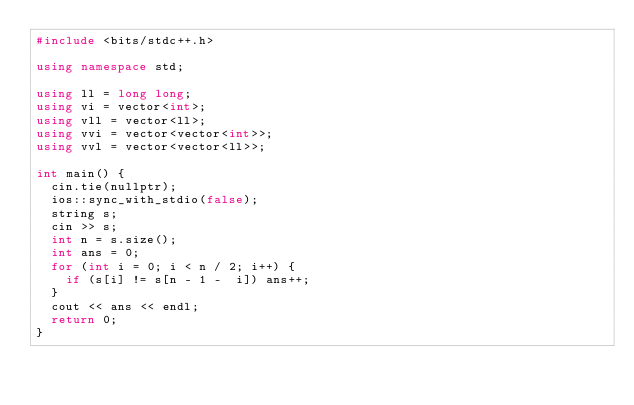Convert code to text. <code><loc_0><loc_0><loc_500><loc_500><_C++_>#include <bits/stdc++.h>

using namespace std;

using ll = long long;
using vi = vector<int>;
using vll = vector<ll>;
using vvi = vector<vector<int>>;
using vvl = vector<vector<ll>>;

int main() {
  cin.tie(nullptr);
  ios::sync_with_stdio(false);
  string s;
  cin >> s;
  int n = s.size();
  int ans = 0;
  for (int i = 0; i < n / 2; i++) {
    if (s[i] != s[n - 1 -  i]) ans++;
  }
  cout << ans << endl;
  return 0;
}
</code> 